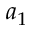Convert formula to latex. <formula><loc_0><loc_0><loc_500><loc_500>a _ { 1 }</formula> 